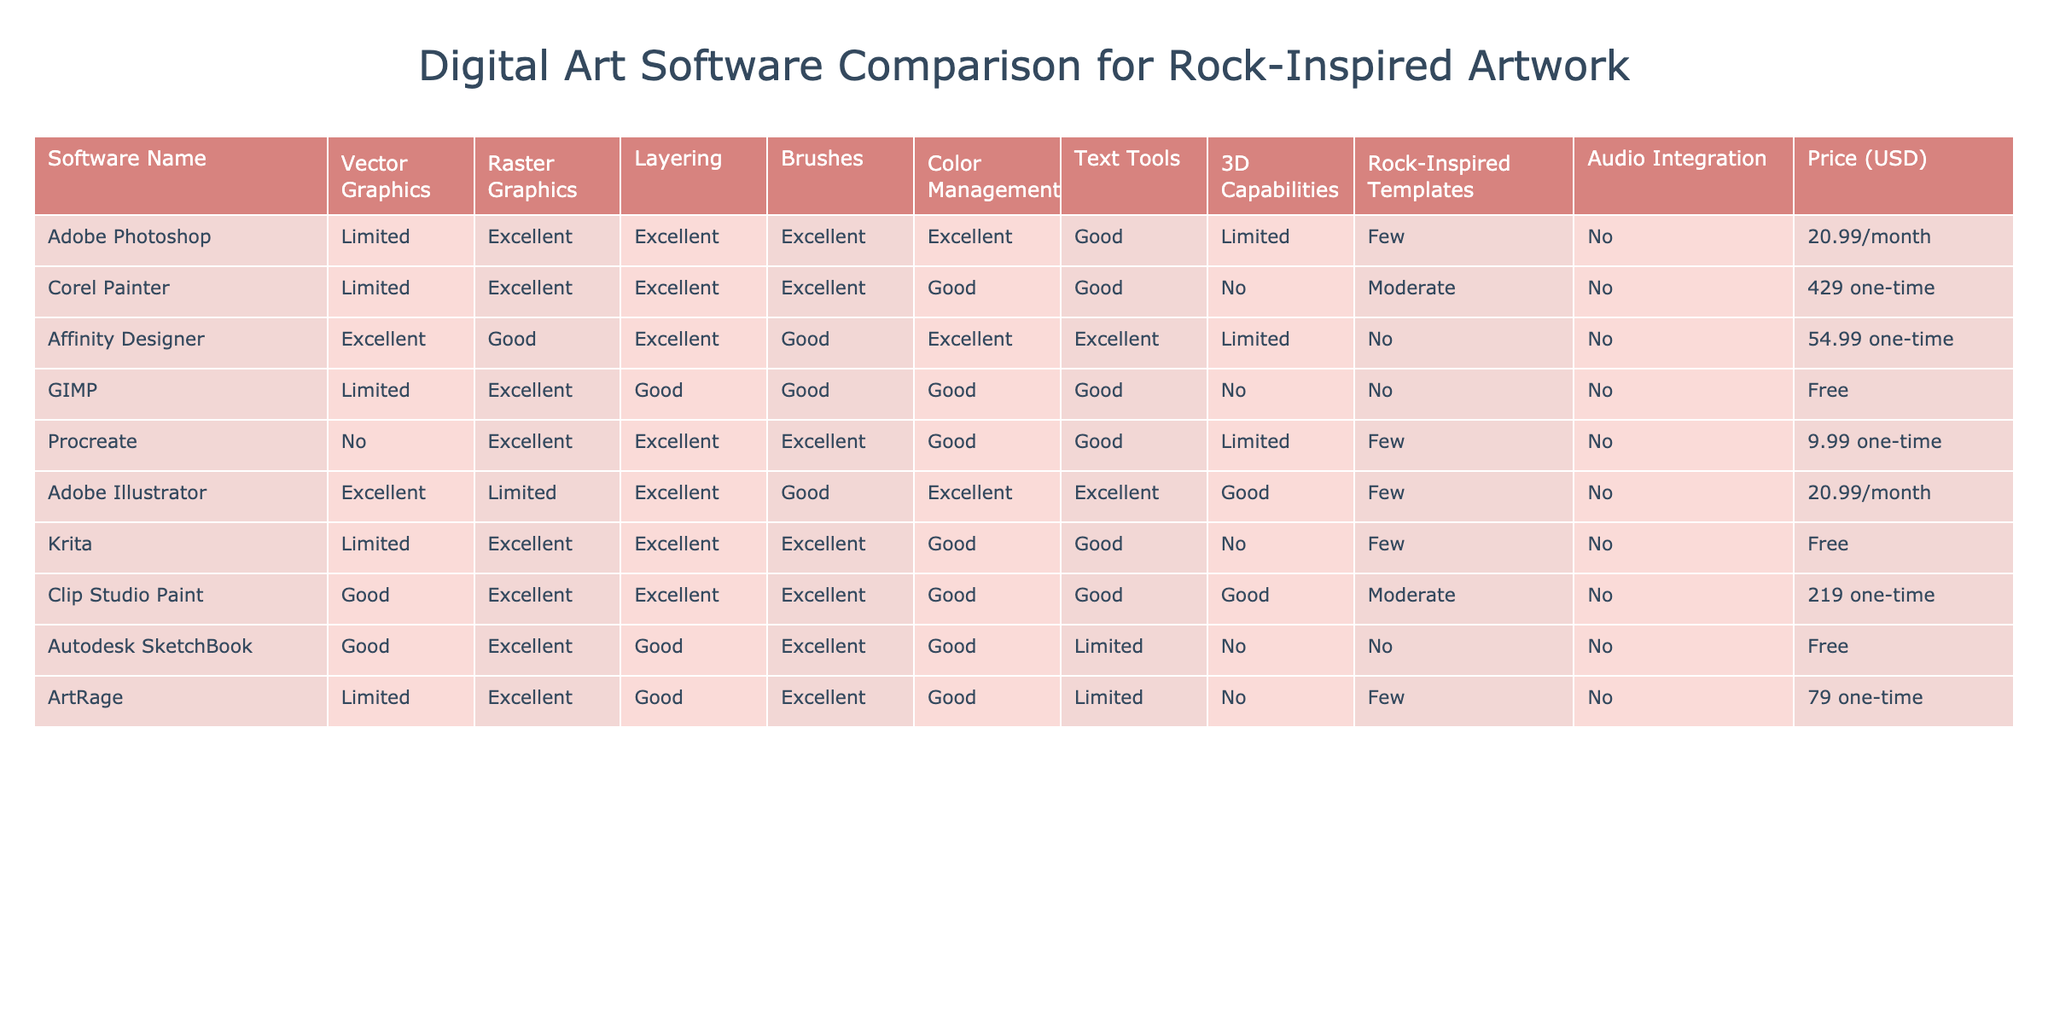What digital art software has the lowest price? According to the table, GIMP is marked as free, while all other software has a price associated with them. This indicates that GIMP has the lowest price.
Answer: GIMP Which software offers excellent raster graphics and 3D capabilities? The table shows that Adobe Illustrator offers excellent raster graphics but lacks 3D capabilities. Conversely, Clip Studio Paint has excellent raster graphics and good 3D capabilities. The only software meeting both criteria is Clip Studio Paint.
Answer: Clip Studio Paint How many software options provide audio integration? When examining the table, it shows that all the software listed have "No" under the audio integration column, leading to the conclusion that none provide this feature.
Answer: None Which software has the best layering capability? The table indicates that Adobe Photoshop and Adobe Illustrator both have excellent layering capabilities, making them the best in this feature.
Answer: Adobe Photoshop and Adobe Illustrator What is the total cost of using Adobe software for one year? Adobe offers Photoshop and Illustrator at a monthly fee of $20.99. When calculating for 12 months, it amounts to 12 * 20.99 = 251.88, which is the total yearly cost.
Answer: 251.88 Which digital art software provides rock-inspired templates? Reviewing the table, it shows that Clip Studio Paint provides good templates, while Procreate and several others offer few. Thus, Clip Studio Paint has the most rock-inspired templates.
Answer: Clip Studio Paint Is Corel Painter a cost-effective option for digital artists? Corel Painter is labeled with a one-time cost of $429, which is significantly higher compared to other software options. Therefore, it is not considered cost-effective.
Answer: No What percentage of the software listed offers excellent brush capabilities? Six out of the eight software options listed have excellent brush capabilities. To find the percentage, we calculate (6/8)*100 which gives us 75%.
Answer: 75% Which software is best for digital artists focusing on classic rock elements specifically? Based on the table, Clip Studio Paint appears to be the most comprehensive choice with its excellent capabilities in raster graphics, layering, brushes, and good rock-inspired templates, even though it lacks specific rock-themed templates.
Answer: Clip Studio Paint 